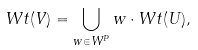<formula> <loc_0><loc_0><loc_500><loc_500>W t ( V ) = \bigcup _ { w \in W ^ { P } } w \cdot W t ( U ) ,</formula> 